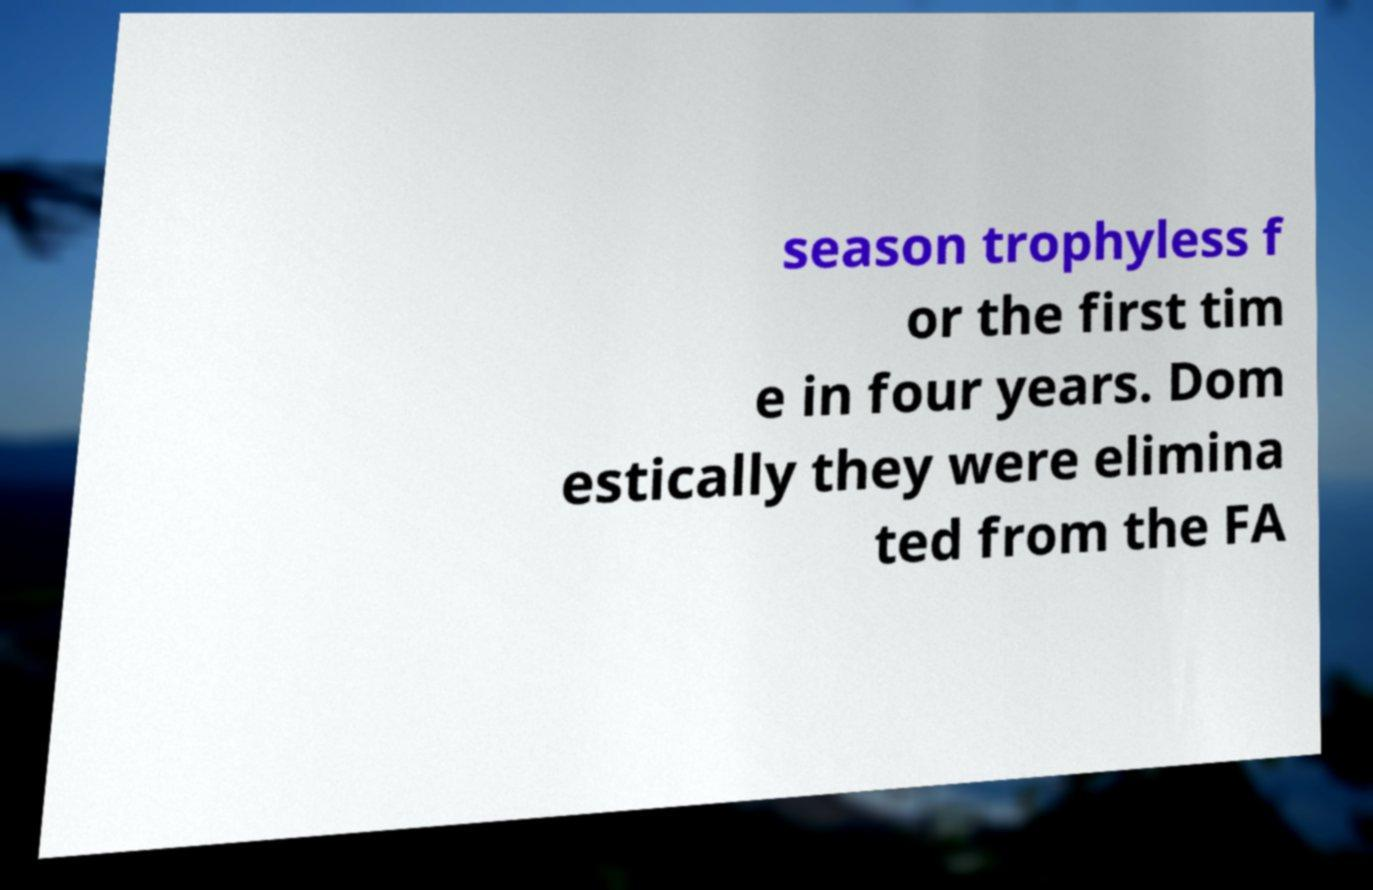There's text embedded in this image that I need extracted. Can you transcribe it verbatim? season trophyless f or the first tim e in four years. Dom estically they were elimina ted from the FA 